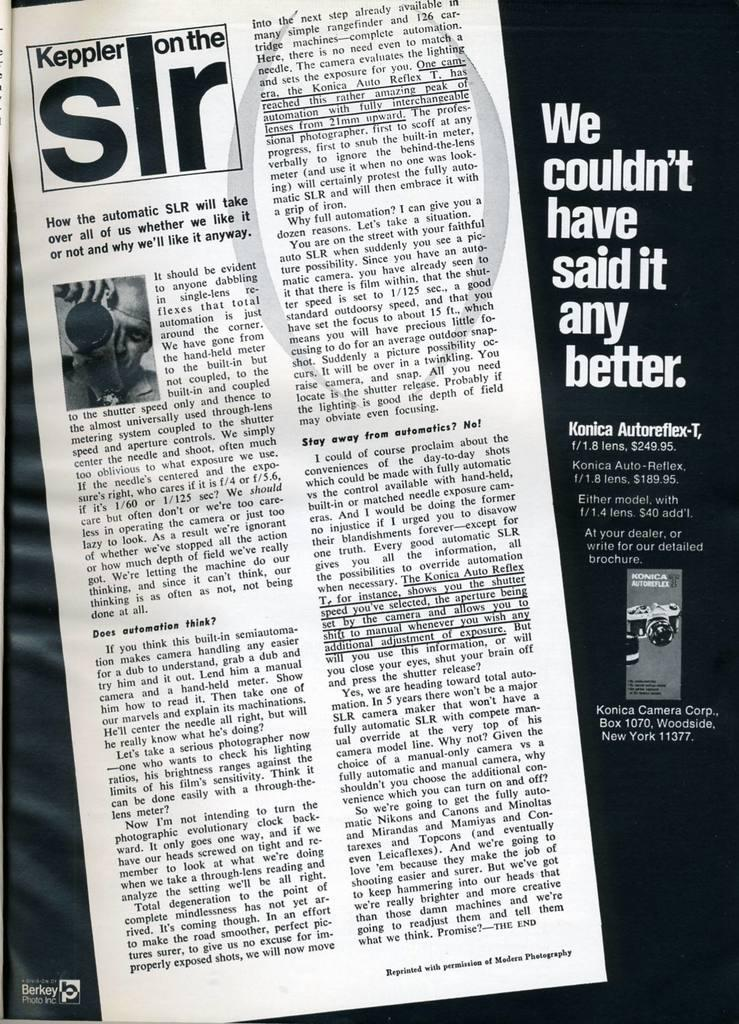What is the main object in the center of the image? There is a newspaper in the center of the image. What can be found on the newspaper? There is text on the newspaper. What else is present on the right side of the image? There is text and an object on the right side of the image. What type of store can be seen in the image? There is no store present in the image; it features a newspaper and text on the right side. How does the iron help with the care of the newspaper in the image? There is no iron present in the image, and the newspaper does not require care from an iron. 